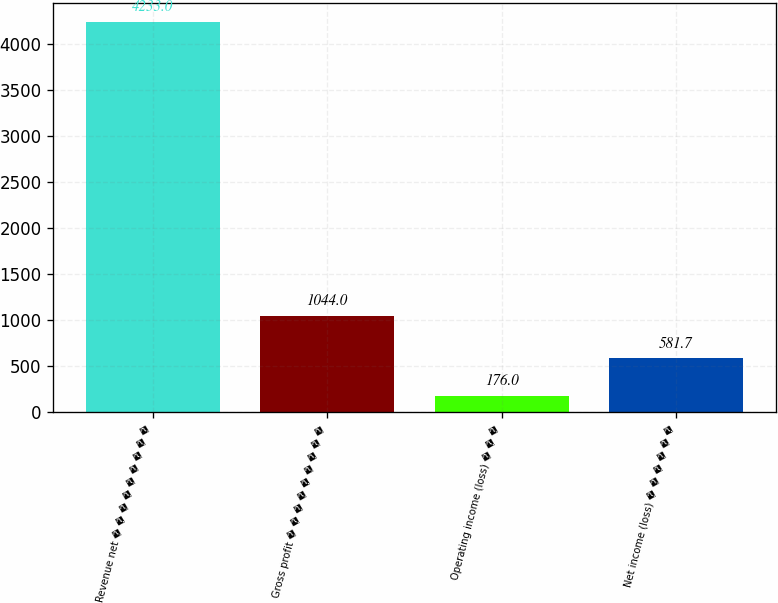Convert chart. <chart><loc_0><loc_0><loc_500><loc_500><bar_chart><fcel>Revenue net � � � � � � � � �<fcel>Gross profit � � � � � � � � �<fcel>Operating income (loss) � � �<fcel>Net income (loss) � � � � � �<nl><fcel>4233<fcel>1044<fcel>176<fcel>581.7<nl></chart> 